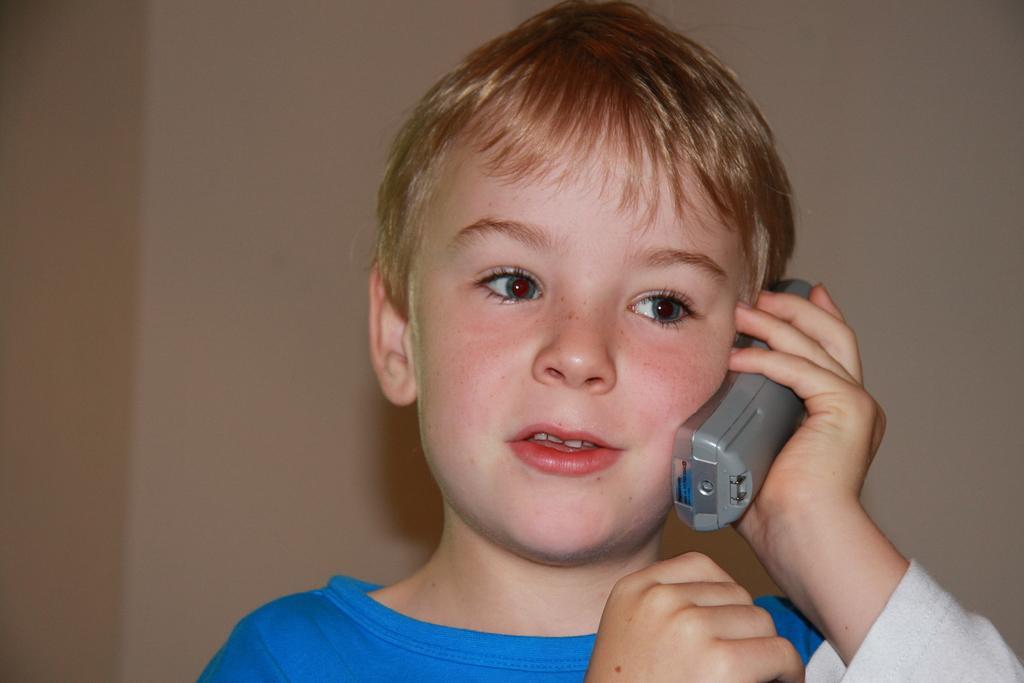Describe this image in one or two sentences. In this image we can see a boy holding an object which looks like a mobile phone and in the background we can see the wall. 